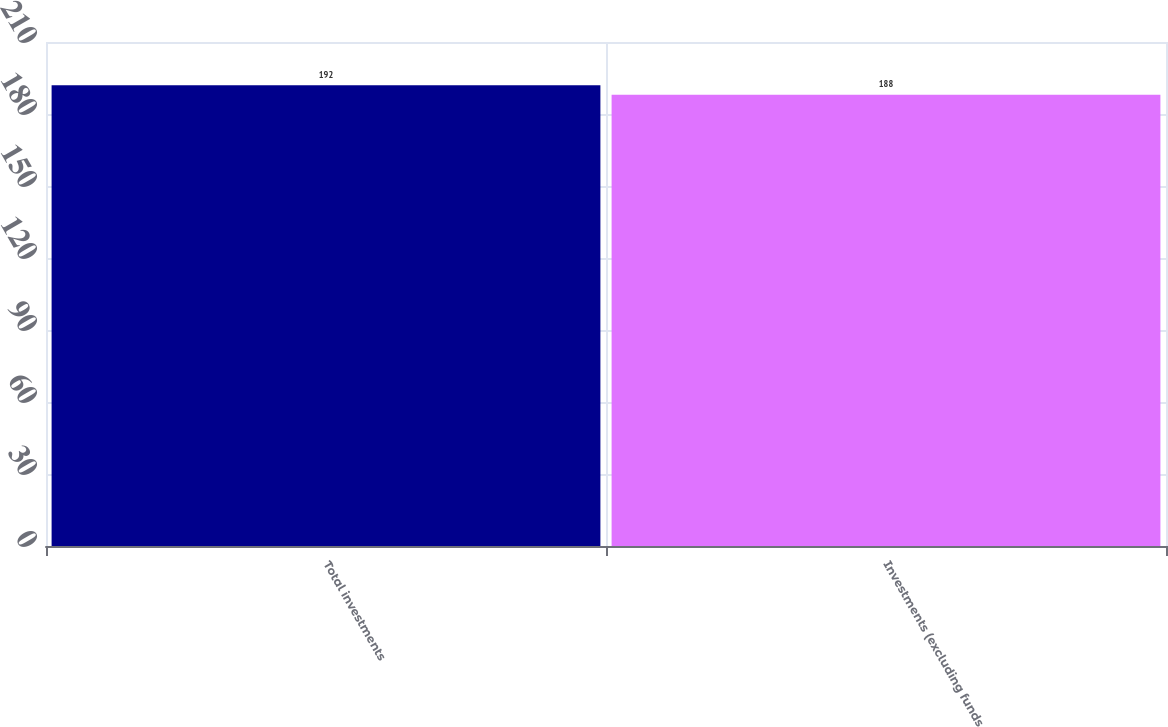Convert chart to OTSL. <chart><loc_0><loc_0><loc_500><loc_500><bar_chart><fcel>Total investments<fcel>Investments (excluding funds<nl><fcel>192<fcel>188<nl></chart> 